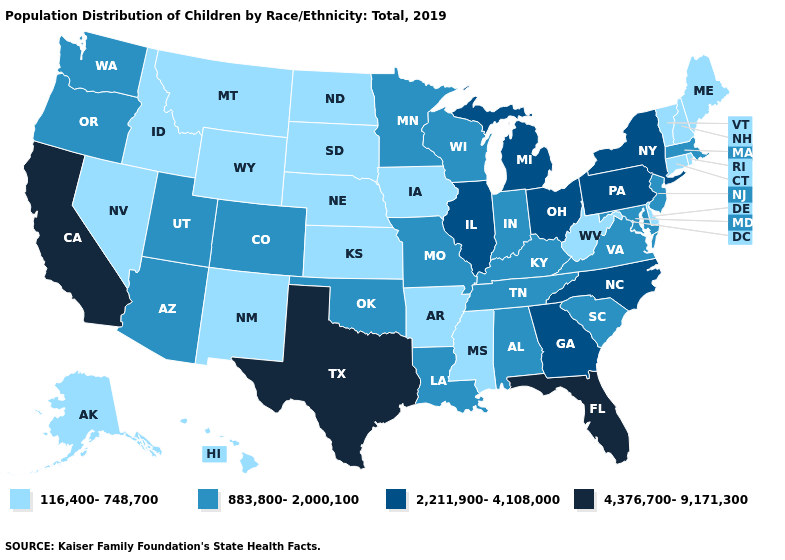Among the states that border Ohio , does West Virginia have the lowest value?
Concise answer only. Yes. Name the states that have a value in the range 883,800-2,000,100?
Concise answer only. Alabama, Arizona, Colorado, Indiana, Kentucky, Louisiana, Maryland, Massachusetts, Minnesota, Missouri, New Jersey, Oklahoma, Oregon, South Carolina, Tennessee, Utah, Virginia, Washington, Wisconsin. Name the states that have a value in the range 4,376,700-9,171,300?
Quick response, please. California, Florida, Texas. Does the map have missing data?
Write a very short answer. No. What is the highest value in the USA?
Concise answer only. 4,376,700-9,171,300. Name the states that have a value in the range 116,400-748,700?
Keep it brief. Alaska, Arkansas, Connecticut, Delaware, Hawaii, Idaho, Iowa, Kansas, Maine, Mississippi, Montana, Nebraska, Nevada, New Hampshire, New Mexico, North Dakota, Rhode Island, South Dakota, Vermont, West Virginia, Wyoming. Name the states that have a value in the range 4,376,700-9,171,300?
Quick response, please. California, Florida, Texas. What is the value of Nebraska?
Write a very short answer. 116,400-748,700. What is the value of Arkansas?
Give a very brief answer. 116,400-748,700. What is the highest value in the USA?
Keep it brief. 4,376,700-9,171,300. What is the value of Kentucky?
Short answer required. 883,800-2,000,100. How many symbols are there in the legend?
Short answer required. 4. Name the states that have a value in the range 883,800-2,000,100?
Quick response, please. Alabama, Arizona, Colorado, Indiana, Kentucky, Louisiana, Maryland, Massachusetts, Minnesota, Missouri, New Jersey, Oklahoma, Oregon, South Carolina, Tennessee, Utah, Virginia, Washington, Wisconsin. Does Idaho have the same value as Wyoming?
Short answer required. Yes. Which states have the lowest value in the USA?
Answer briefly. Alaska, Arkansas, Connecticut, Delaware, Hawaii, Idaho, Iowa, Kansas, Maine, Mississippi, Montana, Nebraska, Nevada, New Hampshire, New Mexico, North Dakota, Rhode Island, South Dakota, Vermont, West Virginia, Wyoming. 